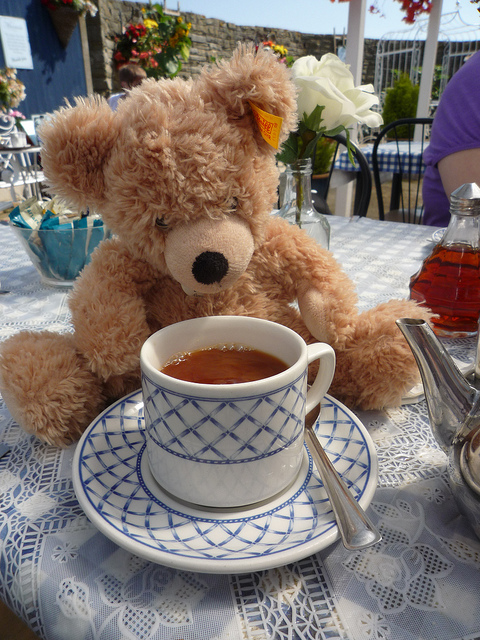What emotions or feelings does this scene evoke? This scene evokes feelings of warmth and comfort, reminiscent of a cozy afternoon tea break. The teddy bear adds a sense of nostalgia and innocence, often associated with childhood memories. Overall, the image creates a tranquil and soothing ambiance. 